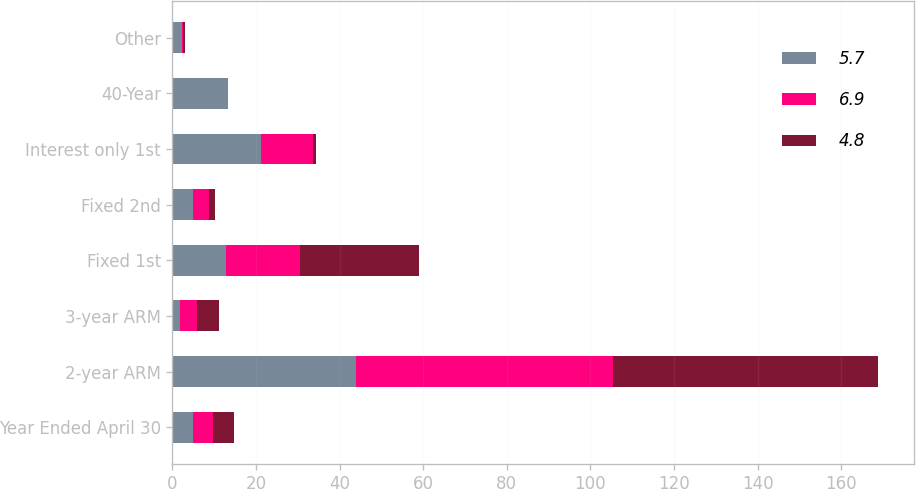Convert chart. <chart><loc_0><loc_0><loc_500><loc_500><stacked_bar_chart><ecel><fcel>Year Ended April 30<fcel>2-year ARM<fcel>3-year ARM<fcel>Fixed 1st<fcel>Fixed 2nd<fcel>Interest only 1st<fcel>40-Year<fcel>Other<nl><fcel>5.7<fcel>4.9<fcel>43.9<fcel>1.9<fcel>12.7<fcel>4.9<fcel>21.1<fcel>13.4<fcel>2.2<nl><fcel>6.9<fcel>4.9<fcel>61.6<fcel>4<fcel>17.7<fcel>3.8<fcel>12.6<fcel>0<fcel>0.3<nl><fcel>4.8<fcel>4.9<fcel>63.4<fcel>5.2<fcel>28.7<fcel>1.6<fcel>0.7<fcel>0<fcel>0.4<nl></chart> 